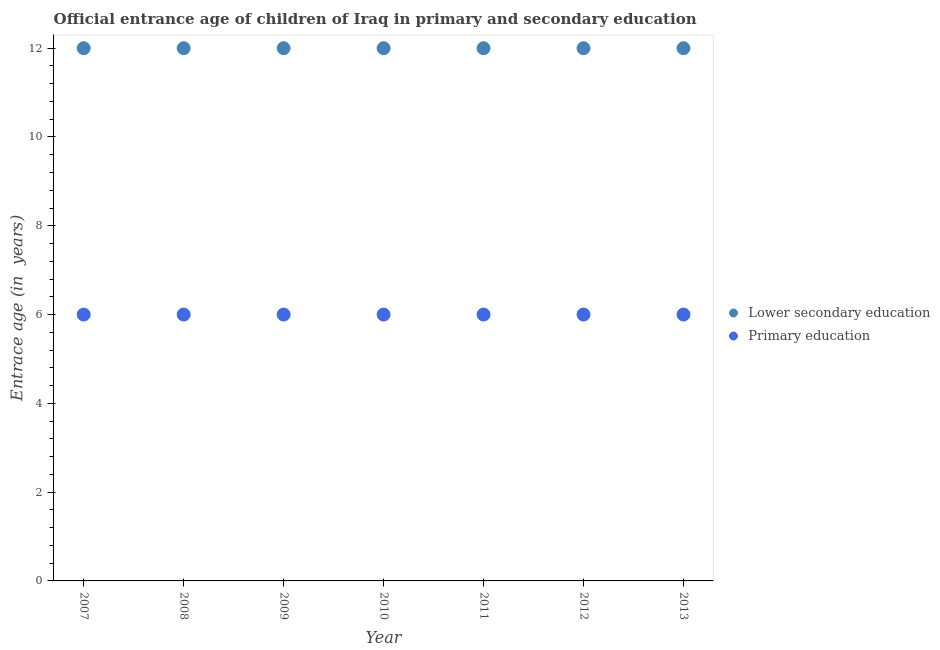How many different coloured dotlines are there?
Your answer should be compact. 2. What is the entrance age of chiildren in primary education in 2013?
Offer a terse response. 6. Across all years, what is the minimum entrance age of children in lower secondary education?
Offer a terse response. 12. In which year was the entrance age of chiildren in primary education maximum?
Your answer should be very brief. 2007. In which year was the entrance age of children in lower secondary education minimum?
Keep it short and to the point. 2007. What is the total entrance age of children in lower secondary education in the graph?
Offer a terse response. 84. What is the difference between the entrance age of chiildren in primary education in 2011 and the entrance age of children in lower secondary education in 2013?
Give a very brief answer. -6. What is the average entrance age of children in lower secondary education per year?
Make the answer very short. 12. What is the ratio of the entrance age of chiildren in primary education in 2009 to that in 2012?
Make the answer very short. 1. In how many years, is the entrance age of children in lower secondary education greater than the average entrance age of children in lower secondary education taken over all years?
Your answer should be compact. 0. Is the sum of the entrance age of children in lower secondary education in 2007 and 2012 greater than the maximum entrance age of chiildren in primary education across all years?
Ensure brevity in your answer.  Yes. Does the entrance age of chiildren in primary education monotonically increase over the years?
Offer a very short reply. No. Is the entrance age of chiildren in primary education strictly greater than the entrance age of children in lower secondary education over the years?
Ensure brevity in your answer.  No. Is the entrance age of chiildren in primary education strictly less than the entrance age of children in lower secondary education over the years?
Give a very brief answer. Yes. What is the difference between two consecutive major ticks on the Y-axis?
Provide a succinct answer. 2. Are the values on the major ticks of Y-axis written in scientific E-notation?
Provide a short and direct response. No. Does the graph contain any zero values?
Offer a terse response. No. Does the graph contain grids?
Offer a terse response. No. How many legend labels are there?
Your answer should be compact. 2. What is the title of the graph?
Your answer should be very brief. Official entrance age of children of Iraq in primary and secondary education. Does "Public funds" appear as one of the legend labels in the graph?
Offer a terse response. No. What is the label or title of the X-axis?
Keep it short and to the point. Year. What is the label or title of the Y-axis?
Provide a short and direct response. Entrace age (in  years). What is the Entrace age (in  years) of Primary education in 2007?
Your answer should be very brief. 6. What is the Entrace age (in  years) in Primary education in 2008?
Keep it short and to the point. 6. What is the Entrace age (in  years) in Primary education in 2010?
Keep it short and to the point. 6. What is the Entrace age (in  years) of Lower secondary education in 2012?
Provide a succinct answer. 12. Across all years, what is the minimum Entrace age (in  years) of Lower secondary education?
Give a very brief answer. 12. What is the total Entrace age (in  years) of Lower secondary education in the graph?
Keep it short and to the point. 84. What is the difference between the Entrace age (in  years) in Lower secondary education in 2007 and that in 2009?
Provide a short and direct response. 0. What is the difference between the Entrace age (in  years) in Lower secondary education in 2007 and that in 2010?
Provide a short and direct response. 0. What is the difference between the Entrace age (in  years) of Lower secondary education in 2007 and that in 2011?
Ensure brevity in your answer.  0. What is the difference between the Entrace age (in  years) in Lower secondary education in 2007 and that in 2012?
Ensure brevity in your answer.  0. What is the difference between the Entrace age (in  years) of Primary education in 2007 and that in 2012?
Your response must be concise. 0. What is the difference between the Entrace age (in  years) in Primary education in 2007 and that in 2013?
Offer a very short reply. 0. What is the difference between the Entrace age (in  years) of Lower secondary education in 2008 and that in 2009?
Your answer should be compact. 0. What is the difference between the Entrace age (in  years) in Lower secondary education in 2008 and that in 2012?
Give a very brief answer. 0. What is the difference between the Entrace age (in  years) in Lower secondary education in 2008 and that in 2013?
Your response must be concise. 0. What is the difference between the Entrace age (in  years) of Primary education in 2009 and that in 2010?
Keep it short and to the point. 0. What is the difference between the Entrace age (in  years) in Lower secondary education in 2009 and that in 2011?
Provide a short and direct response. 0. What is the difference between the Entrace age (in  years) in Lower secondary education in 2009 and that in 2012?
Your answer should be compact. 0. What is the difference between the Entrace age (in  years) of Lower secondary education in 2009 and that in 2013?
Make the answer very short. 0. What is the difference between the Entrace age (in  years) of Primary education in 2009 and that in 2013?
Provide a succinct answer. 0. What is the difference between the Entrace age (in  years) in Primary education in 2010 and that in 2011?
Give a very brief answer. 0. What is the difference between the Entrace age (in  years) in Lower secondary education in 2010 and that in 2012?
Provide a short and direct response. 0. What is the difference between the Entrace age (in  years) of Primary education in 2010 and that in 2012?
Make the answer very short. 0. What is the difference between the Entrace age (in  years) in Lower secondary education in 2010 and that in 2013?
Give a very brief answer. 0. What is the difference between the Entrace age (in  years) in Primary education in 2010 and that in 2013?
Ensure brevity in your answer.  0. What is the difference between the Entrace age (in  years) in Lower secondary education in 2011 and that in 2012?
Keep it short and to the point. 0. What is the difference between the Entrace age (in  years) of Lower secondary education in 2011 and that in 2013?
Your answer should be very brief. 0. What is the difference between the Entrace age (in  years) of Lower secondary education in 2012 and that in 2013?
Offer a terse response. 0. What is the difference between the Entrace age (in  years) in Primary education in 2012 and that in 2013?
Offer a very short reply. 0. What is the difference between the Entrace age (in  years) of Lower secondary education in 2007 and the Entrace age (in  years) of Primary education in 2009?
Offer a terse response. 6. What is the difference between the Entrace age (in  years) of Lower secondary education in 2007 and the Entrace age (in  years) of Primary education in 2013?
Ensure brevity in your answer.  6. What is the difference between the Entrace age (in  years) in Lower secondary education in 2008 and the Entrace age (in  years) in Primary education in 2009?
Your response must be concise. 6. What is the difference between the Entrace age (in  years) in Lower secondary education in 2008 and the Entrace age (in  years) in Primary education in 2011?
Your response must be concise. 6. What is the difference between the Entrace age (in  years) in Lower secondary education in 2009 and the Entrace age (in  years) in Primary education in 2010?
Offer a very short reply. 6. What is the difference between the Entrace age (in  years) of Lower secondary education in 2009 and the Entrace age (in  years) of Primary education in 2013?
Offer a very short reply. 6. What is the difference between the Entrace age (in  years) in Lower secondary education in 2010 and the Entrace age (in  years) in Primary education in 2011?
Ensure brevity in your answer.  6. What is the difference between the Entrace age (in  years) in Lower secondary education in 2010 and the Entrace age (in  years) in Primary education in 2012?
Provide a succinct answer. 6. What is the difference between the Entrace age (in  years) of Lower secondary education in 2012 and the Entrace age (in  years) of Primary education in 2013?
Provide a succinct answer. 6. What is the average Entrace age (in  years) of Primary education per year?
Offer a very short reply. 6. In the year 2010, what is the difference between the Entrace age (in  years) in Lower secondary education and Entrace age (in  years) in Primary education?
Your answer should be compact. 6. In the year 2011, what is the difference between the Entrace age (in  years) in Lower secondary education and Entrace age (in  years) in Primary education?
Provide a succinct answer. 6. In the year 2013, what is the difference between the Entrace age (in  years) of Lower secondary education and Entrace age (in  years) of Primary education?
Provide a short and direct response. 6. What is the ratio of the Entrace age (in  years) of Lower secondary education in 2007 to that in 2008?
Your answer should be compact. 1. What is the ratio of the Entrace age (in  years) of Lower secondary education in 2007 to that in 2009?
Offer a very short reply. 1. What is the ratio of the Entrace age (in  years) of Primary education in 2007 to that in 2009?
Offer a very short reply. 1. What is the ratio of the Entrace age (in  years) in Lower secondary education in 2007 to that in 2010?
Provide a short and direct response. 1. What is the ratio of the Entrace age (in  years) of Primary education in 2007 to that in 2011?
Offer a terse response. 1. What is the ratio of the Entrace age (in  years) of Primary education in 2007 to that in 2013?
Give a very brief answer. 1. What is the ratio of the Entrace age (in  years) of Lower secondary education in 2008 to that in 2009?
Provide a succinct answer. 1. What is the ratio of the Entrace age (in  years) in Primary education in 2008 to that in 2009?
Your response must be concise. 1. What is the ratio of the Entrace age (in  years) in Primary education in 2008 to that in 2010?
Provide a short and direct response. 1. What is the ratio of the Entrace age (in  years) in Primary education in 2008 to that in 2011?
Offer a very short reply. 1. What is the ratio of the Entrace age (in  years) in Lower secondary education in 2008 to that in 2012?
Your answer should be compact. 1. What is the ratio of the Entrace age (in  years) in Primary education in 2008 to that in 2012?
Offer a very short reply. 1. What is the ratio of the Entrace age (in  years) in Primary education in 2008 to that in 2013?
Your answer should be very brief. 1. What is the ratio of the Entrace age (in  years) in Primary education in 2010 to that in 2012?
Your answer should be very brief. 1. What is the ratio of the Entrace age (in  years) of Lower secondary education in 2010 to that in 2013?
Give a very brief answer. 1. What is the ratio of the Entrace age (in  years) in Primary education in 2011 to that in 2012?
Offer a very short reply. 1. What is the difference between the highest and the second highest Entrace age (in  years) in Lower secondary education?
Your answer should be compact. 0. 